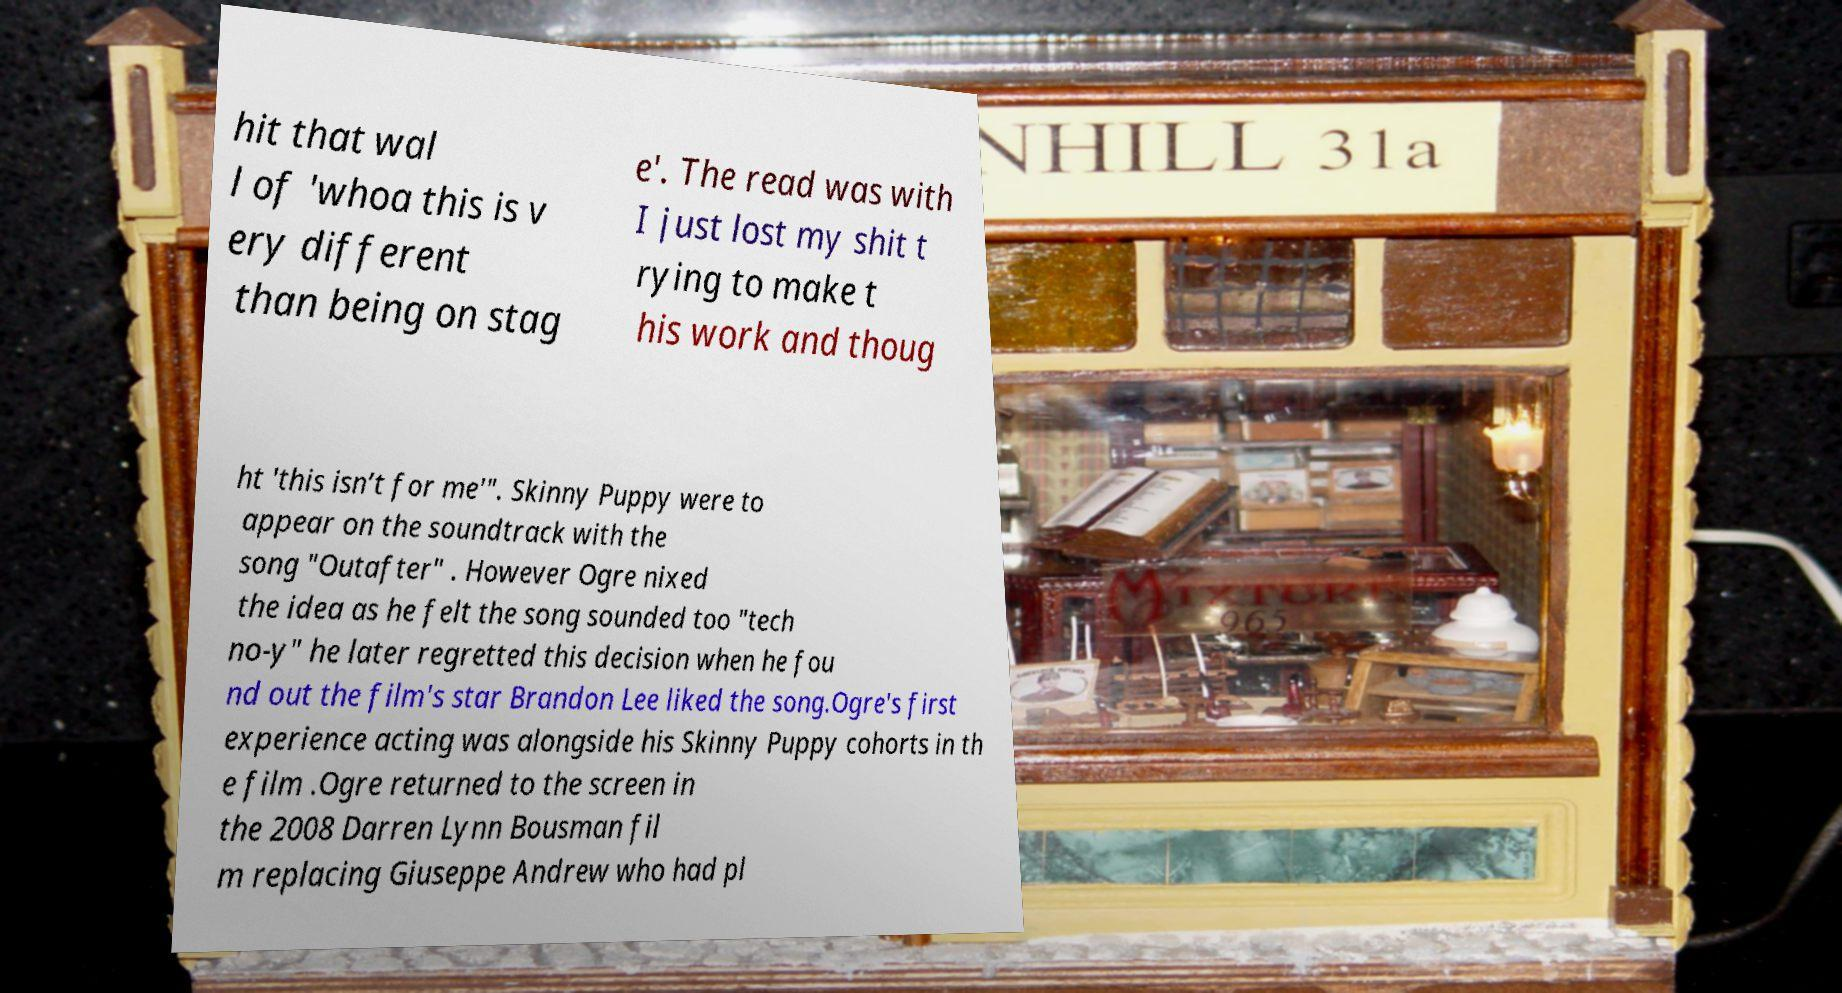There's text embedded in this image that I need extracted. Can you transcribe it verbatim? hit that wal l of 'whoa this is v ery different than being on stag e'. The read was with I just lost my shit t rying to make t his work and thoug ht 'this isn’t for me'". Skinny Puppy were to appear on the soundtrack with the song "Outafter" . However Ogre nixed the idea as he felt the song sounded too "tech no-y" he later regretted this decision when he fou nd out the film's star Brandon Lee liked the song.Ogre's first experience acting was alongside his Skinny Puppy cohorts in th e film .Ogre returned to the screen in the 2008 Darren Lynn Bousman fil m replacing Giuseppe Andrew who had pl 